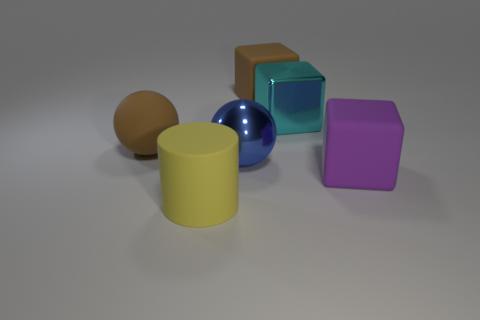Add 4 brown rubber balls. How many objects exist? 10 Subtract 0 purple cylinders. How many objects are left? 6 Subtract all spheres. How many objects are left? 4 Subtract all cyan cylinders. Subtract all purple spheres. How many cylinders are left? 1 Subtract all purple spheres. How many brown cubes are left? 1 Subtract all small gray cylinders. Subtract all cyan metallic blocks. How many objects are left? 5 Add 1 matte things. How many matte things are left? 5 Add 2 big metal objects. How many big metal objects exist? 4 Subtract all cyan blocks. How many blocks are left? 2 Subtract all large brown blocks. How many blocks are left? 2 